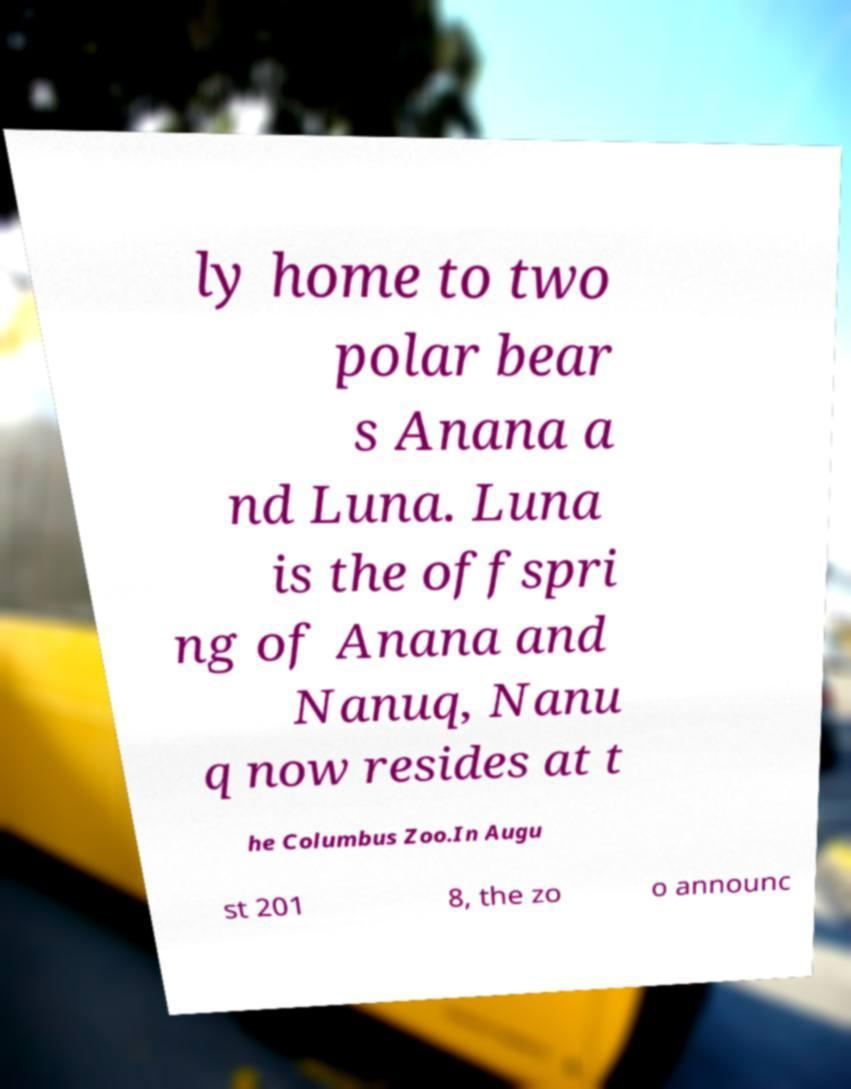Can you accurately transcribe the text from the provided image for me? ly home to two polar bear s Anana a nd Luna. Luna is the offspri ng of Anana and Nanuq, Nanu q now resides at t he Columbus Zoo.In Augu st 201 8, the zo o announc 